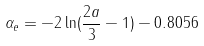<formula> <loc_0><loc_0><loc_500><loc_500>\alpha _ { e } = - 2 \ln ( \frac { 2 a } { 3 } - 1 ) - 0 . 8 0 5 6</formula> 